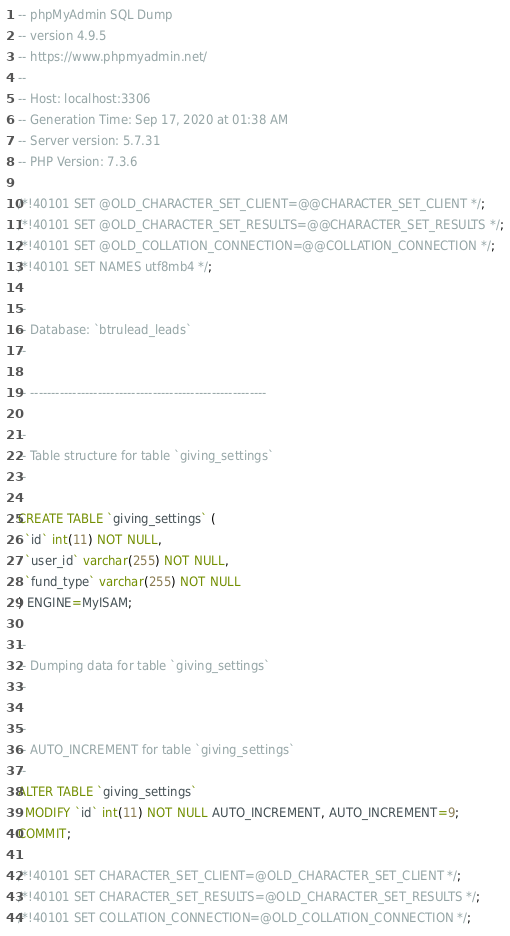Convert code to text. <code><loc_0><loc_0><loc_500><loc_500><_SQL_>-- phpMyAdmin SQL Dump
-- version 4.9.5
-- https://www.phpmyadmin.net/
--
-- Host: localhost:3306
-- Generation Time: Sep 17, 2020 at 01:38 AM
-- Server version: 5.7.31
-- PHP Version: 7.3.6

/*!40101 SET @OLD_CHARACTER_SET_CLIENT=@@CHARACTER_SET_CLIENT */;
/*!40101 SET @OLD_CHARACTER_SET_RESULTS=@@CHARACTER_SET_RESULTS */;
/*!40101 SET @OLD_COLLATION_CONNECTION=@@COLLATION_CONNECTION */;
/*!40101 SET NAMES utf8mb4 */;

--
-- Database: `btrulead_leads`
--

-- --------------------------------------------------------

--
-- Table structure for table `giving_settings`
--

CREATE TABLE `giving_settings` (
  `id` int(11) NOT NULL,
  `user_id` varchar(255) NOT NULL,
  `fund_type` varchar(255) NOT NULL
) ENGINE=MyISAM;

--
-- Dumping data for table `giving_settings`
--

--
-- AUTO_INCREMENT for table `giving_settings`
--
ALTER TABLE `giving_settings`
  MODIFY `id` int(11) NOT NULL AUTO_INCREMENT, AUTO_INCREMENT=9;
COMMIT;

/*!40101 SET CHARACTER_SET_CLIENT=@OLD_CHARACTER_SET_CLIENT */;
/*!40101 SET CHARACTER_SET_RESULTS=@OLD_CHARACTER_SET_RESULTS */;
/*!40101 SET COLLATION_CONNECTION=@OLD_COLLATION_CONNECTION */;
</code> 